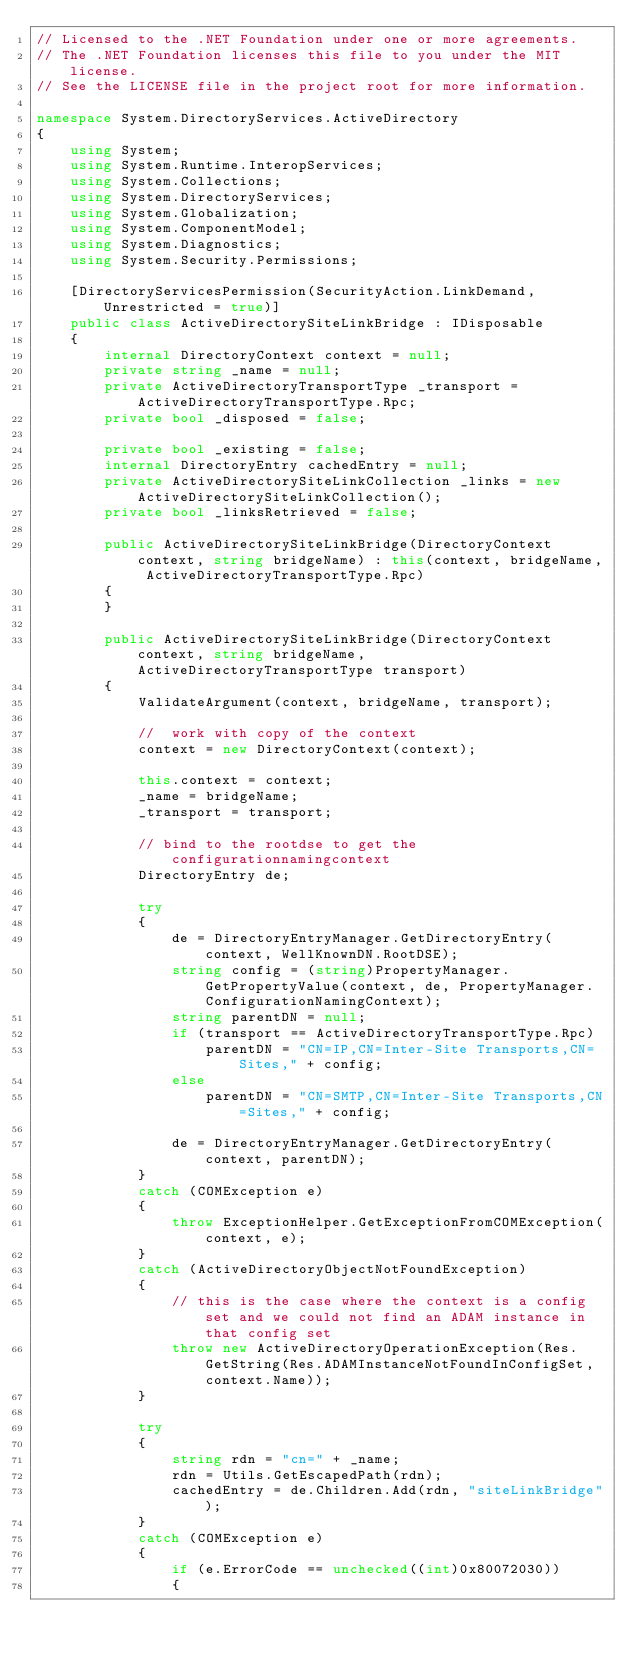<code> <loc_0><loc_0><loc_500><loc_500><_C#_>// Licensed to the .NET Foundation under one or more agreements.
// The .NET Foundation licenses this file to you under the MIT license.
// See the LICENSE file in the project root for more information.

namespace System.DirectoryServices.ActiveDirectory
{
    using System;
    using System.Runtime.InteropServices;
    using System.Collections;
    using System.DirectoryServices;
    using System.Globalization;
    using System.ComponentModel;
    using System.Diagnostics;
    using System.Security.Permissions;

    [DirectoryServicesPermission(SecurityAction.LinkDemand, Unrestricted = true)]
    public class ActiveDirectorySiteLinkBridge : IDisposable
    {
        internal DirectoryContext context = null;
        private string _name = null;
        private ActiveDirectoryTransportType _transport = ActiveDirectoryTransportType.Rpc;
        private bool _disposed = false;

        private bool _existing = false;
        internal DirectoryEntry cachedEntry = null;
        private ActiveDirectorySiteLinkCollection _links = new ActiveDirectorySiteLinkCollection();
        private bool _linksRetrieved = false;

        public ActiveDirectorySiteLinkBridge(DirectoryContext context, string bridgeName) : this(context, bridgeName, ActiveDirectoryTransportType.Rpc)
        {
        }

        public ActiveDirectorySiteLinkBridge(DirectoryContext context, string bridgeName, ActiveDirectoryTransportType transport)
        {
            ValidateArgument(context, bridgeName, transport);

            //  work with copy of the context
            context = new DirectoryContext(context);

            this.context = context;
            _name = bridgeName;
            _transport = transport;

            // bind to the rootdse to get the configurationnamingcontext
            DirectoryEntry de;

            try
            {
                de = DirectoryEntryManager.GetDirectoryEntry(context, WellKnownDN.RootDSE);
                string config = (string)PropertyManager.GetPropertyValue(context, de, PropertyManager.ConfigurationNamingContext);
                string parentDN = null;
                if (transport == ActiveDirectoryTransportType.Rpc)
                    parentDN = "CN=IP,CN=Inter-Site Transports,CN=Sites," + config;
                else
                    parentDN = "CN=SMTP,CN=Inter-Site Transports,CN=Sites," + config;

                de = DirectoryEntryManager.GetDirectoryEntry(context, parentDN);
            }
            catch (COMException e)
            {
                throw ExceptionHelper.GetExceptionFromCOMException(context, e);
            }
            catch (ActiveDirectoryObjectNotFoundException)
            {
                // this is the case where the context is a config set and we could not find an ADAM instance in that config set
                throw new ActiveDirectoryOperationException(Res.GetString(Res.ADAMInstanceNotFoundInConfigSet, context.Name));
            }

            try
            {
                string rdn = "cn=" + _name;
                rdn = Utils.GetEscapedPath(rdn);
                cachedEntry = de.Children.Add(rdn, "siteLinkBridge");
            }
            catch (COMException e)
            {
                if (e.ErrorCode == unchecked((int)0x80072030))
                {</code> 